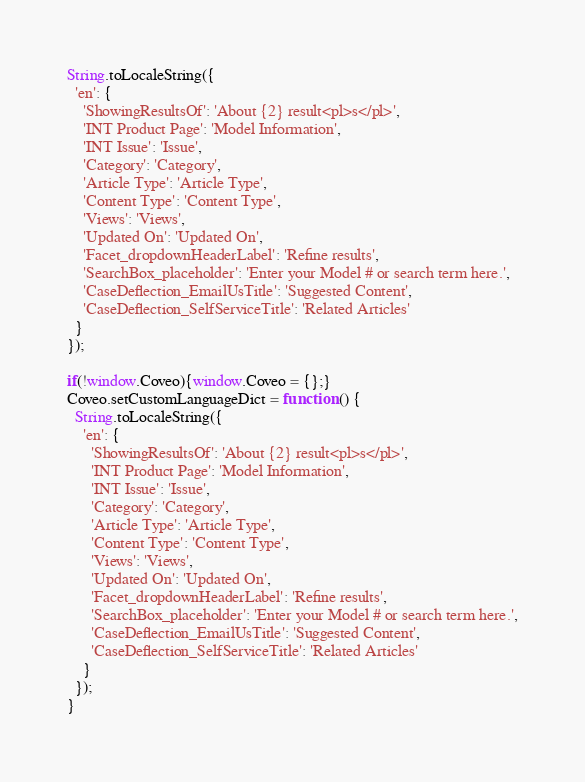Convert code to text. <code><loc_0><loc_0><loc_500><loc_500><_JavaScript_>String.toLocaleString({
  'en': {
    'ShowingResultsOf': 'About {2} result<pl>s</pl>',
    'INT Product Page': 'Model Information',
    'INT Issue': 'Issue',
    'Category': 'Category',
    'Article Type': 'Article Type',
    'Content Type': 'Content Type',
    'Views': 'Views',
    'Updated On': 'Updated On',
    'Facet_dropdownHeaderLabel': 'Refine results',
    'SearchBox_placeholder': 'Enter your Model # or search term here.',
    'CaseDeflection_EmailUsTitle': 'Suggested Content',
    'CaseDeflection_SelfServiceTitle': 'Related Articles'
  }
});

if(!window.Coveo){window.Coveo = {};}
Coveo.setCustomLanguageDict = function () {
  String.toLocaleString({
    'en': {
      'ShowingResultsOf': 'About {2} result<pl>s</pl>',
      'INT Product Page': 'Model Information',
      'INT Issue': 'Issue',
      'Category': 'Category',
      'Article Type': 'Article Type',
      'Content Type': 'Content Type',
      'Views': 'Views',
      'Updated On': 'Updated On',
      'Facet_dropdownHeaderLabel': 'Refine results',
      'SearchBox_placeholder': 'Enter your Model # or search term here.',
      'CaseDeflection_EmailUsTitle': 'Suggested Content',
      'CaseDeflection_SelfServiceTitle': 'Related Articles'
    }
  });
}
</code> 